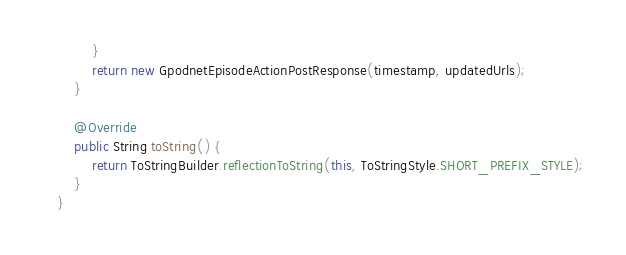Convert code to text. <code><loc_0><loc_0><loc_500><loc_500><_Java_>        }
        return new GpodnetEpisodeActionPostResponse(timestamp, updatedUrls);
    }

    @Override
    public String toString() {
        return ToStringBuilder.reflectionToString(this, ToStringStyle.SHORT_PREFIX_STYLE);
    }
}

</code> 